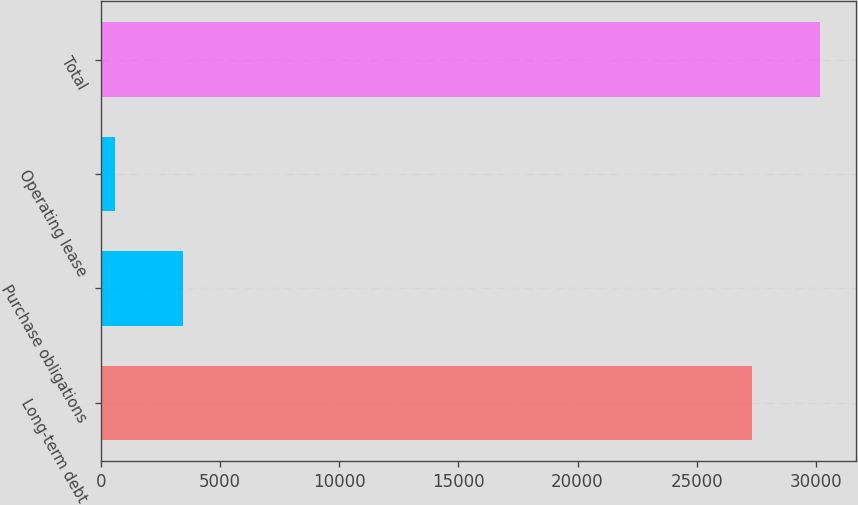<chart> <loc_0><loc_0><loc_500><loc_500><bar_chart><fcel>Long-term debt<fcel>Purchase obligations<fcel>Operating lease<fcel>Total<nl><fcel>27318<fcel>3451.9<fcel>596<fcel>30173.9<nl></chart> 